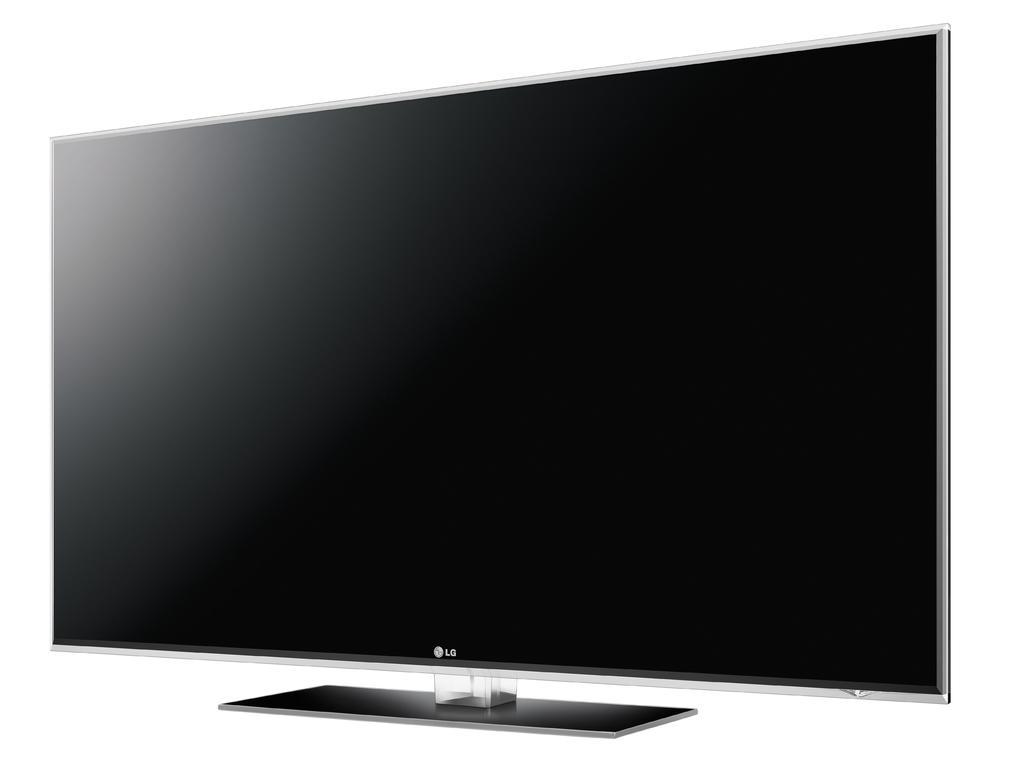Provide a one-sentence caption for the provided image. An unpowered Lg branded television with a white background behind it. 